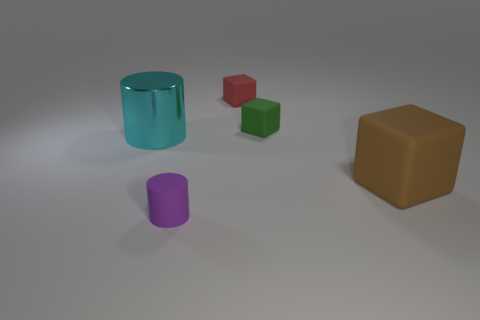Can you tell what time of day it might be based on the lighting in the image? The image doesn't provide clear indicators of the time of day since it's likely a rendered scene with artificial lighting. The absence of natural light sources like the sun or shadows that would indicate the sun's position makes it difficult to deduce the time of day. 